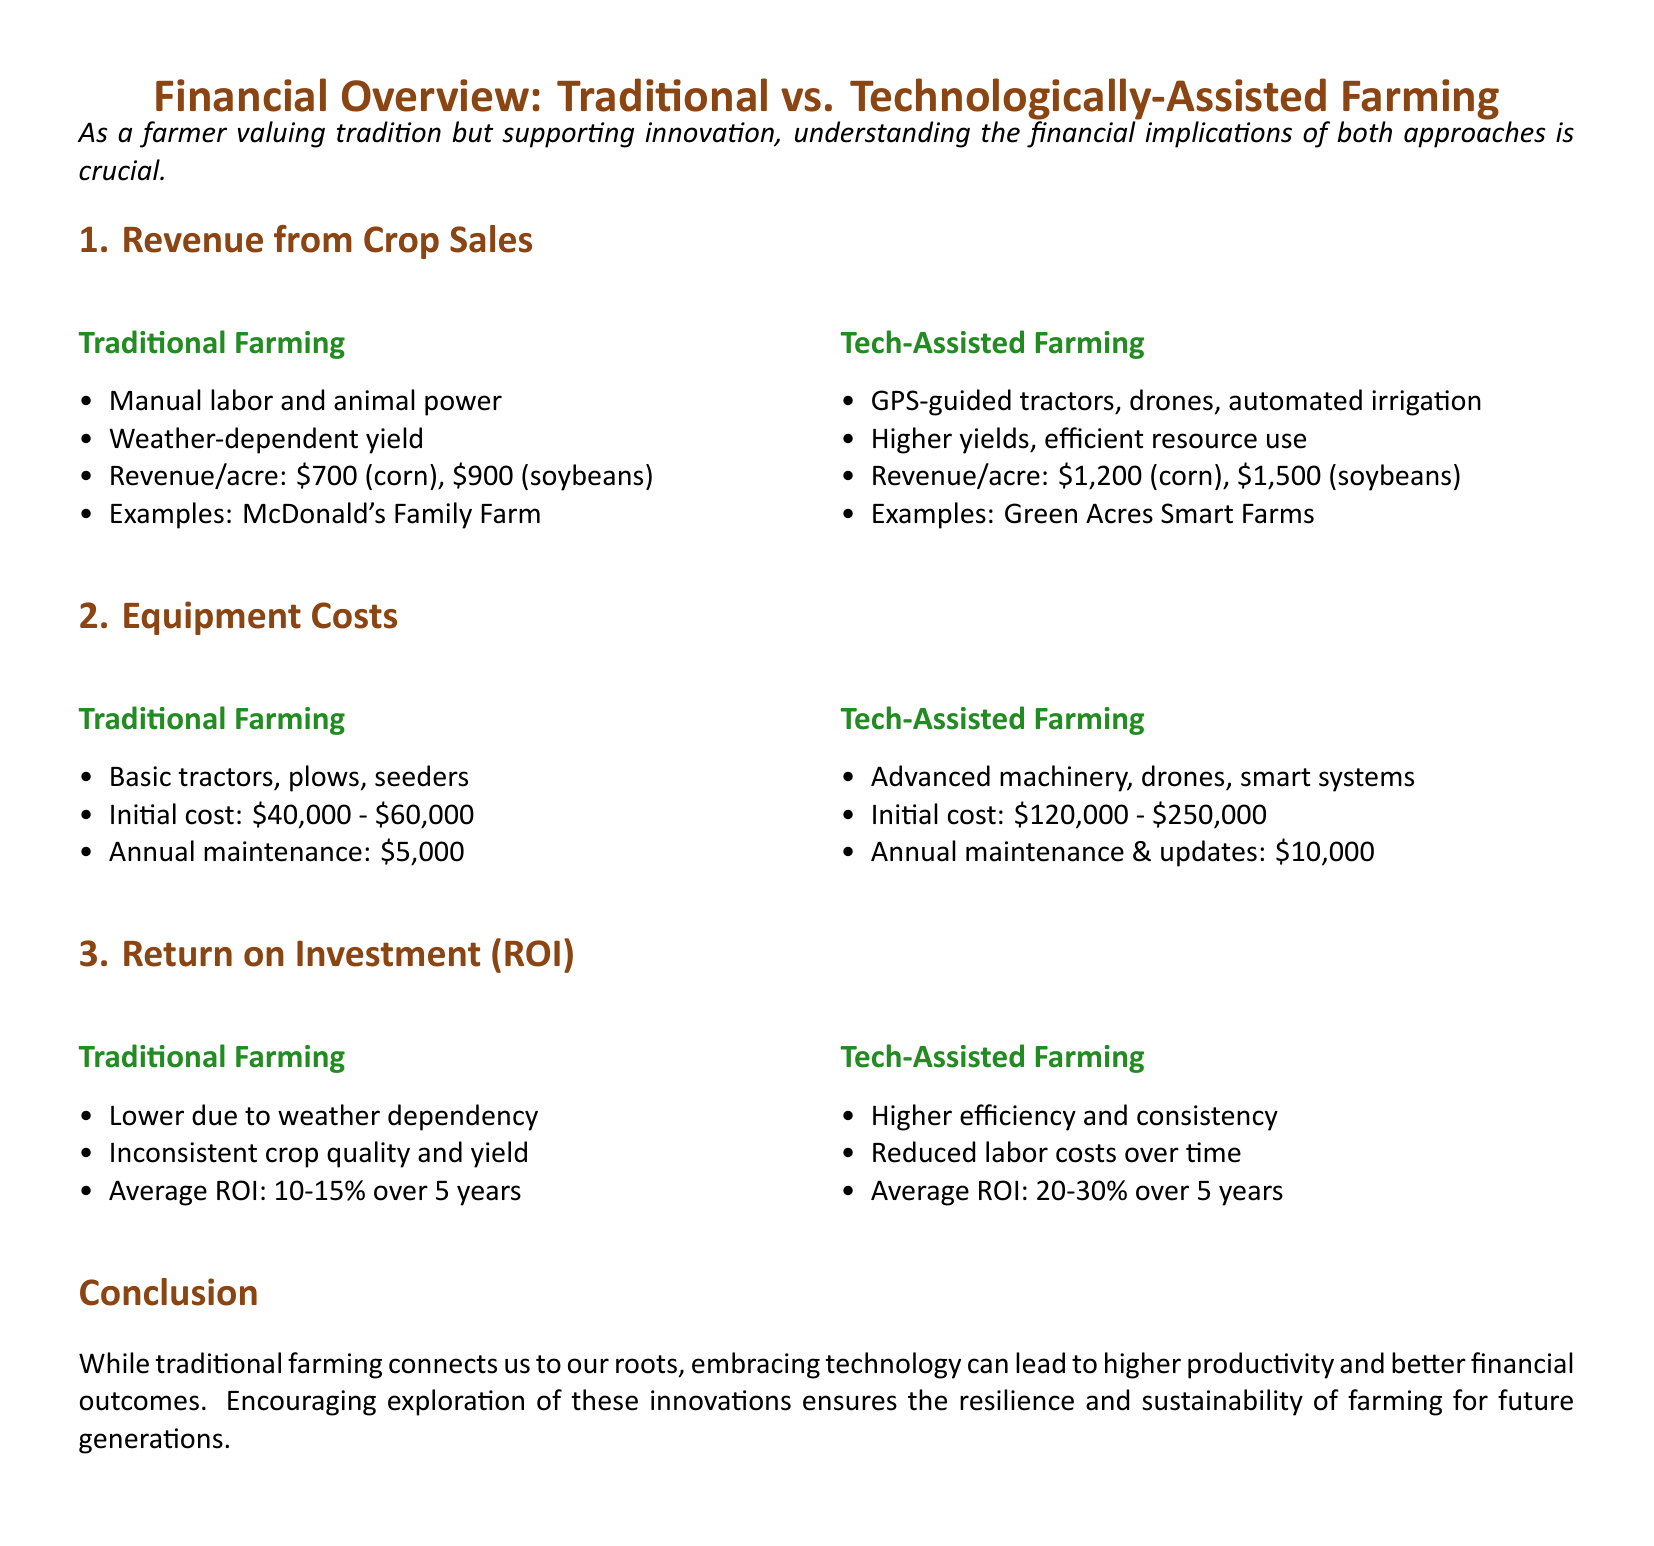What is the revenue per acre for corn in traditional farming? The document states the revenue per acre for corn in traditional farming is $700.
Answer: $700 What is the initial cost range for equipment in tech-assisted farming? The document lists the initial cost range for equipment in tech-assisted farming as $120,000 to $250,000.
Answer: $120,000 - $250,000 What is the average ROI for traditional farming over 5 years? The document mentions the average ROI for traditional farming over 5 years is 10-15%.
Answer: 10-15% Which farming type utilizes drones and GPS-guided tractors? The document categorizes drones and GPS-guided tractors under tech-assisted farming.
Answer: Tech-Assisted Farming What is the annual maintenance cost for traditional farming equipment? According to the document, the annual maintenance cost for traditional farming equipment is $5,000.
Answer: $5,000 What is the revenue per acre for soybeans in tech-assisted farming? The document indicates the revenue per acre for soybeans in tech-assisted farming is $1,500.
Answer: $1,500 What is the average ROI for tech-assisted farming over 5 years? The document states that the average ROI for tech-assisted farming over 5 years is 20-30%.
Answer: 20-30% Which type of farming has lower due to weather dependency? The document specifies that traditional farming has lower ROI due to weather dependency.
Answer: Traditional Farming 